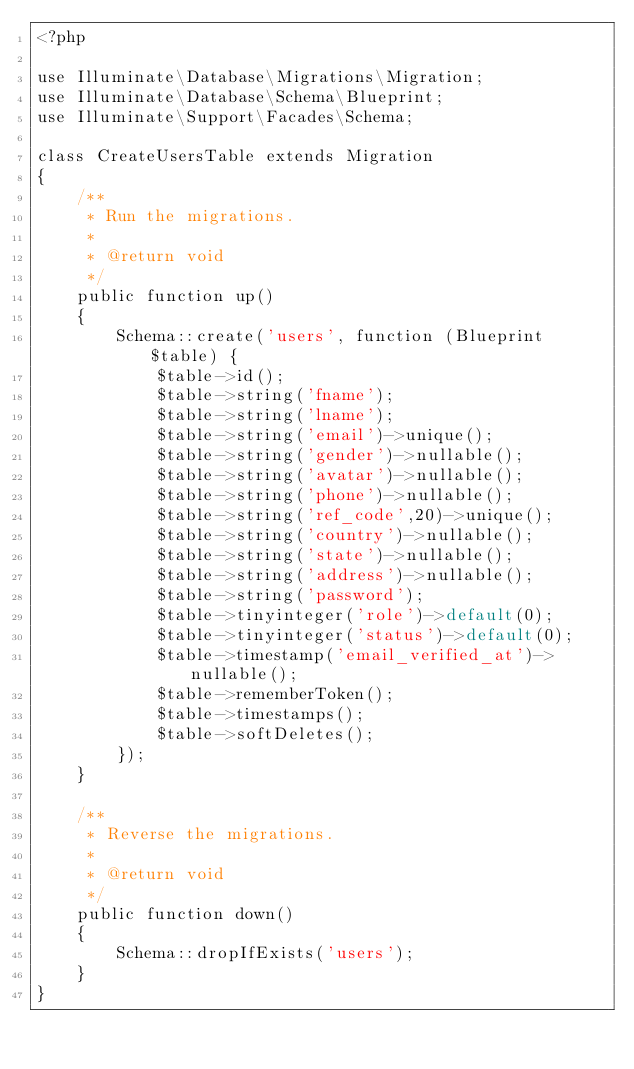<code> <loc_0><loc_0><loc_500><loc_500><_PHP_><?php

use Illuminate\Database\Migrations\Migration;
use Illuminate\Database\Schema\Blueprint;
use Illuminate\Support\Facades\Schema;

class CreateUsersTable extends Migration
{
    /**
     * Run the migrations.
     *
     * @return void
     */
    public function up()
    {
        Schema::create('users', function (Blueprint $table) {
            $table->id();
            $table->string('fname');
            $table->string('lname');
            $table->string('email')->unique();
            $table->string('gender')->nullable();
            $table->string('avatar')->nullable();
            $table->string('phone')->nullable();
            $table->string('ref_code',20)->unique();
            $table->string('country')->nullable();
            $table->string('state')->nullable();
            $table->string('address')->nullable();
            $table->string('password');
            $table->tinyinteger('role')->default(0);
            $table->tinyinteger('status')->default(0);
            $table->timestamp('email_verified_at')->nullable();
            $table->rememberToken();
            $table->timestamps();
            $table->softDeletes();
        });
    }

    /**
     * Reverse the migrations.
     *
     * @return void
     */
    public function down()
    {
        Schema::dropIfExists('users');
    }
}
</code> 